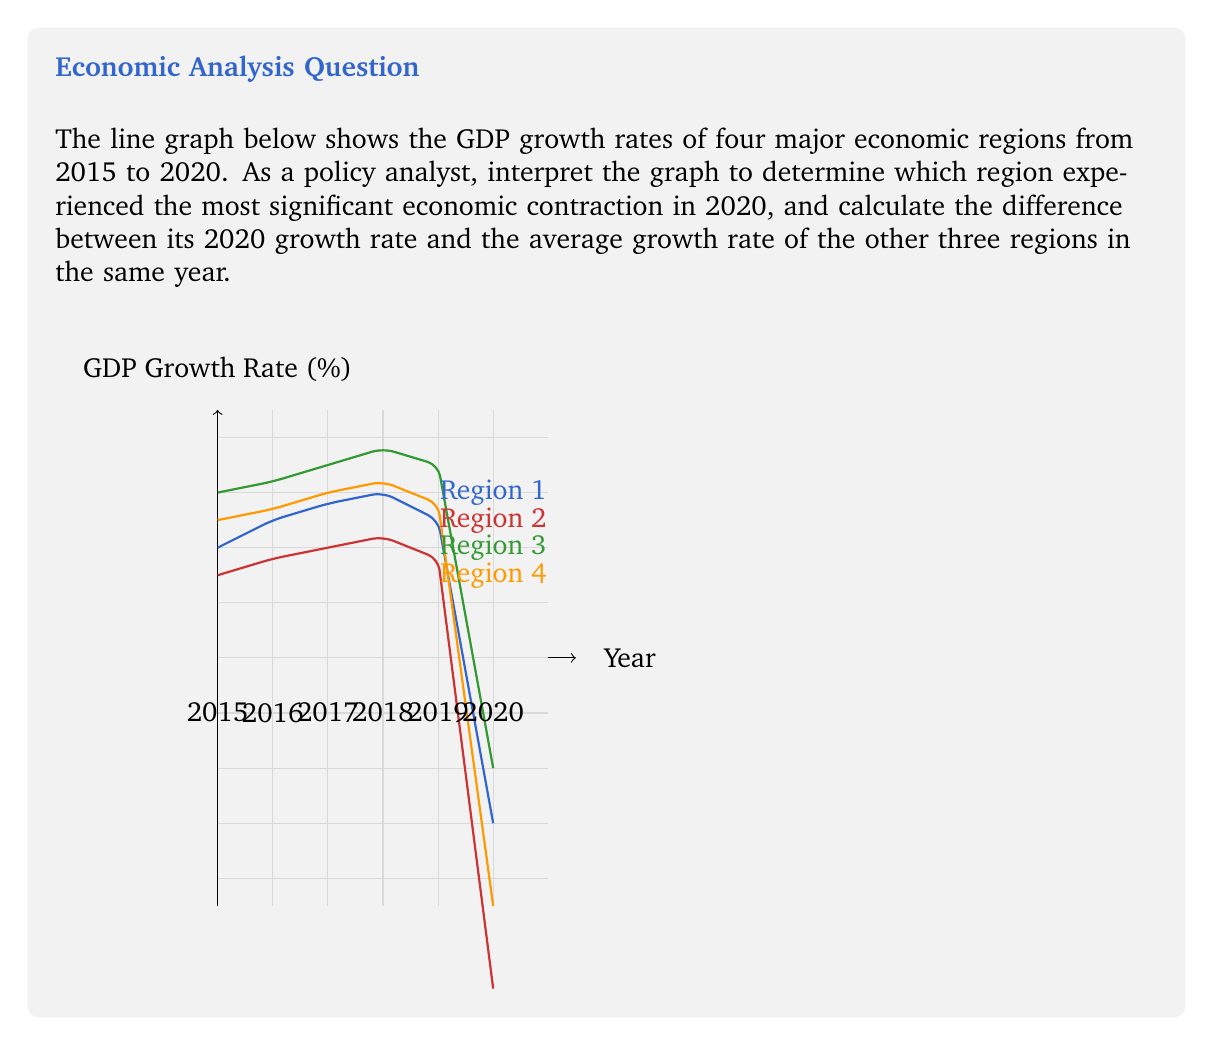Teach me how to tackle this problem. To solve this problem, we need to follow these steps:

1. Identify the region with the most significant economic contraction in 2020:
   Looking at the graph, we can see that all regions experienced negative growth in 2020. Region 2 has the lowest point on the graph in 2020, indicating the most severe contraction at -6% growth.

2. Calculate the average growth rate of the other three regions in 2020:
   Region 1: -3%
   Region 3: -2%
   Region 4: -4.5%

   Average = $\frac{-3 + (-2) + (-4.5)}{3} = \frac{-9.5}{3} = -3.1666...$

3. Calculate the difference between Region 2's growth rate and the average of the others:
   Difference = Region 2's rate - Average of others
               = $-6 - (-3.1666...)$
               = $-2.8333...$

4. Round the result to two decimal places:
   $-2.8333...$ rounded to two decimal places is $-2.83$

Therefore, Region 2 experienced the most significant economic contraction in 2020, and its growth rate was 2.83 percentage points lower than the average of the other three regions.
Answer: -2.83 percentage points 